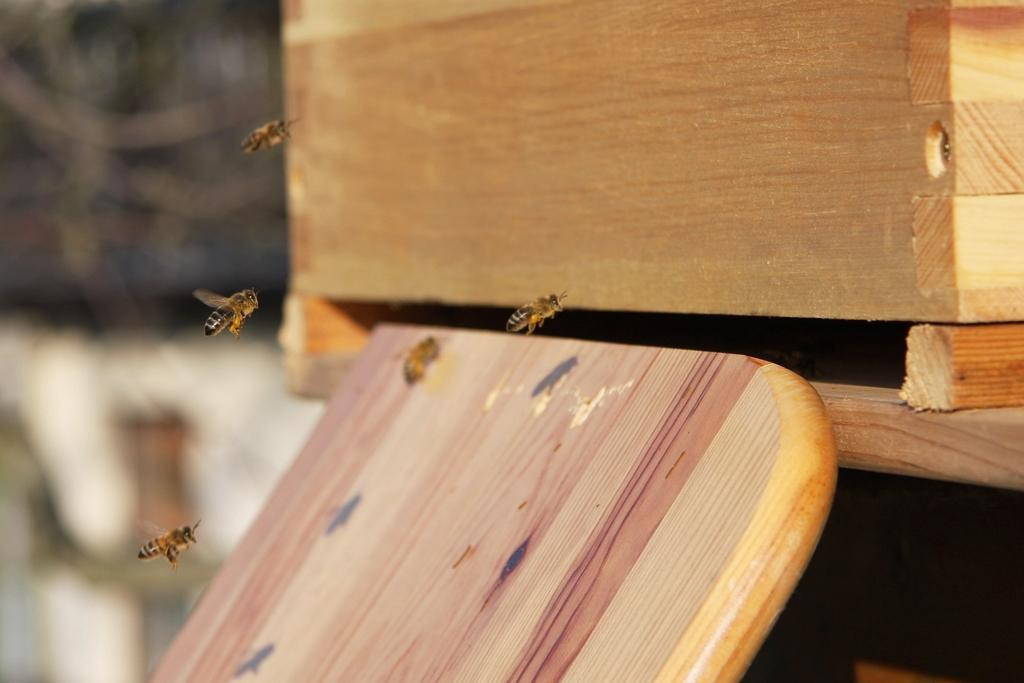What type of insects can be seen in the image? There are honey bees in the image. What material is the plank in the image made of? The wooden plank in the image is made of wood. What object is present in the image that could be used for storage? There is a box in the image that could be used for storage. How would you describe the background of the image? The background of the image is blurry. How many flowers are being held by the honey bees in the image? There are no flowers present in the image; it only features honey bees, a wooden plank, and a box. Can you see any sheep in the image? There are no sheep present in the image. 